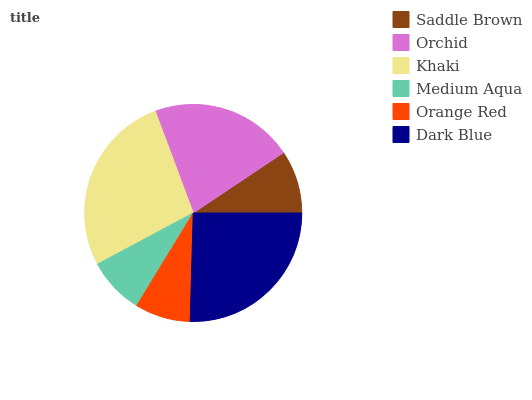Is Orange Red the minimum?
Answer yes or no. Yes. Is Khaki the maximum?
Answer yes or no. Yes. Is Orchid the minimum?
Answer yes or no. No. Is Orchid the maximum?
Answer yes or no. No. Is Orchid greater than Saddle Brown?
Answer yes or no. Yes. Is Saddle Brown less than Orchid?
Answer yes or no. Yes. Is Saddle Brown greater than Orchid?
Answer yes or no. No. Is Orchid less than Saddle Brown?
Answer yes or no. No. Is Orchid the high median?
Answer yes or no. Yes. Is Saddle Brown the low median?
Answer yes or no. Yes. Is Orange Red the high median?
Answer yes or no. No. Is Khaki the low median?
Answer yes or no. No. 